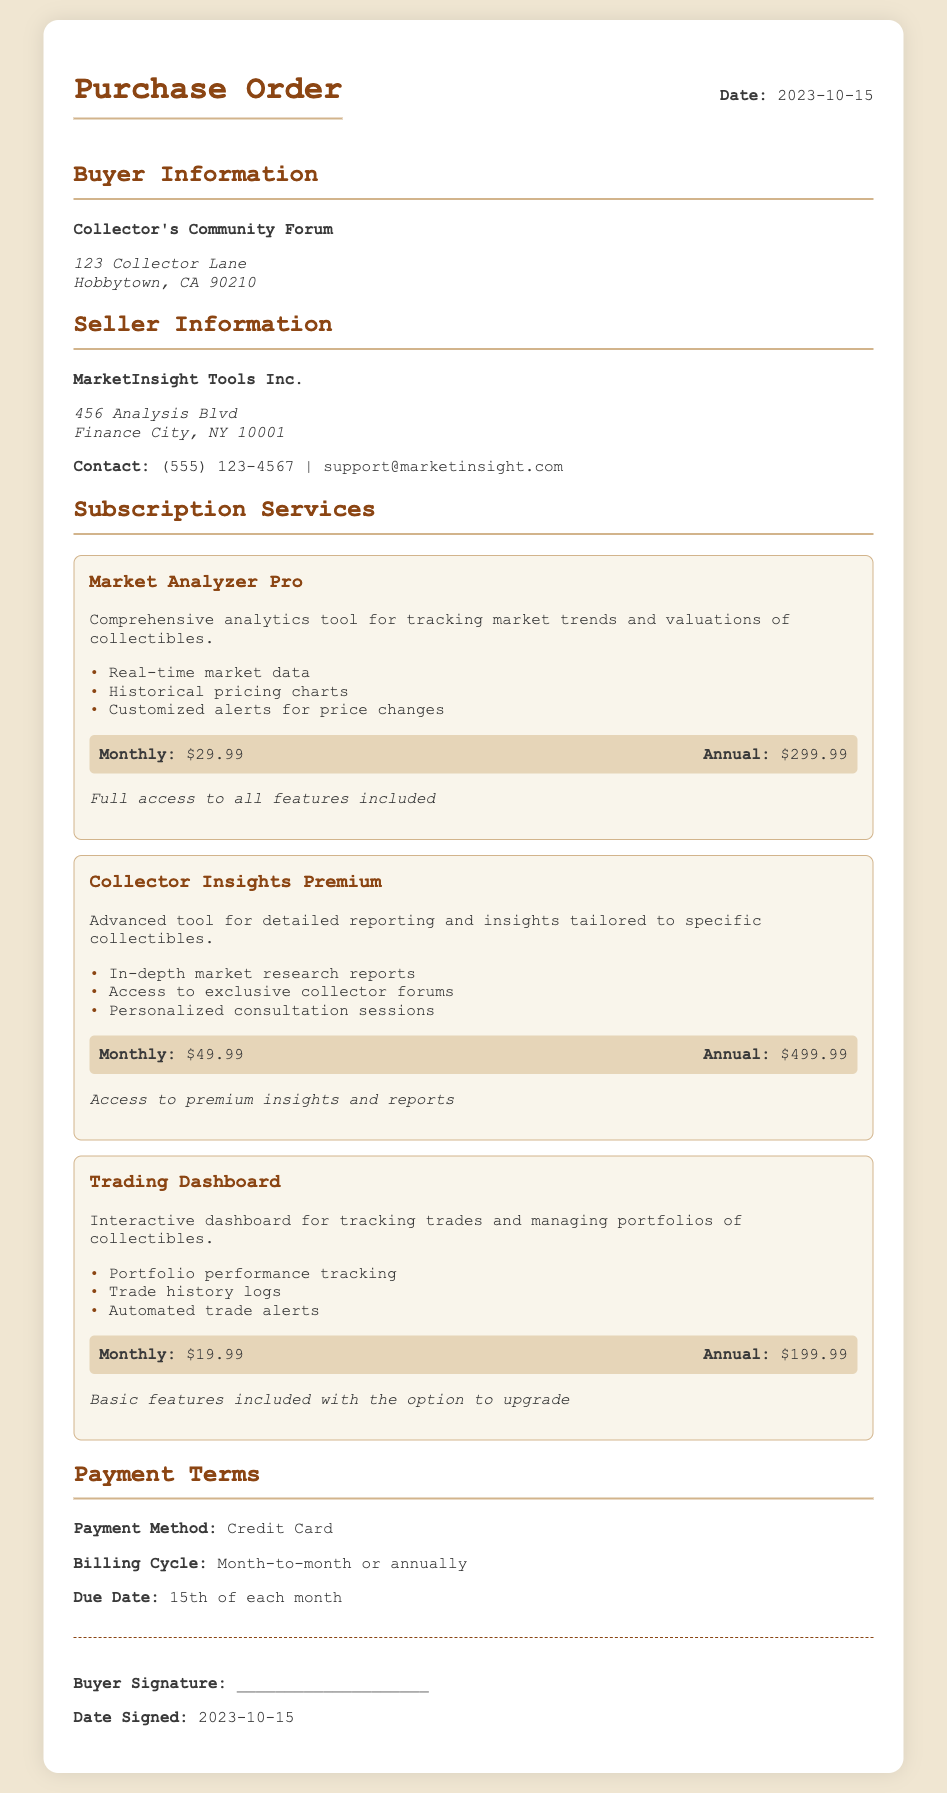What is the date of the purchase order? The purchase order is dated 2023-10-15.
Answer: 2023-10-15 Who is the buyer? The buyer is the Collector's Community Forum.
Answer: Collector's Community Forum What is the price of the Market Analyzer Pro subscription monthly? The monthly price for Market Analyzer Pro is listed in the pricing section as $29.99.
Answer: $29.99 How much does the Trading Dashboard cost annually? The annual cost for the Trading Dashboard is found in the pricing section, which is $199.99.
Answer: $199.99 What is one feature of the Collector Insights Premium subscription? One of the features of Collector Insights Premium is in-depth market research reports.
Answer: In-depth market research reports What payment method is specified in the document? The document states that the payment method is Credit Card.
Answer: Credit Card What is the due date for payments? Payments are due on the 15th of each month as indicated in the payment terms.
Answer: 15th of each month Which subscription has the highest monthly cost? The subscription with the highest monthly cost is Collector Insights Premium, priced at $49.99.
Answer: Collector Insights Premium 